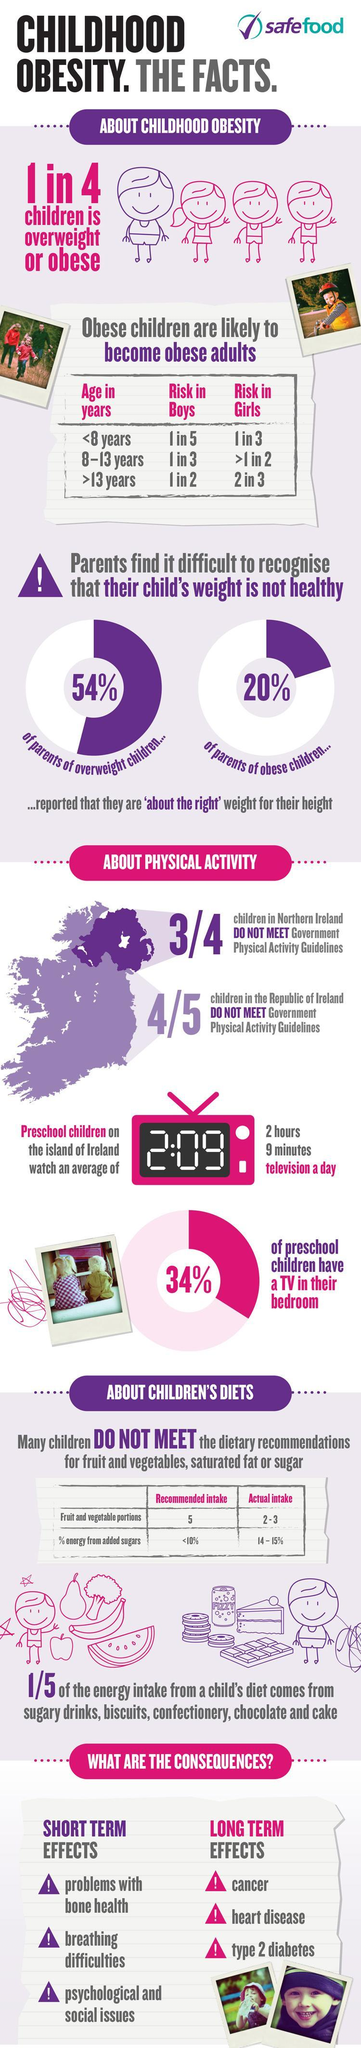Boys in which age group has high risk of obesity?
Answer the question with a short phrase. > 13 years What percent of preschool children do not have tv in bedroom? 46% 